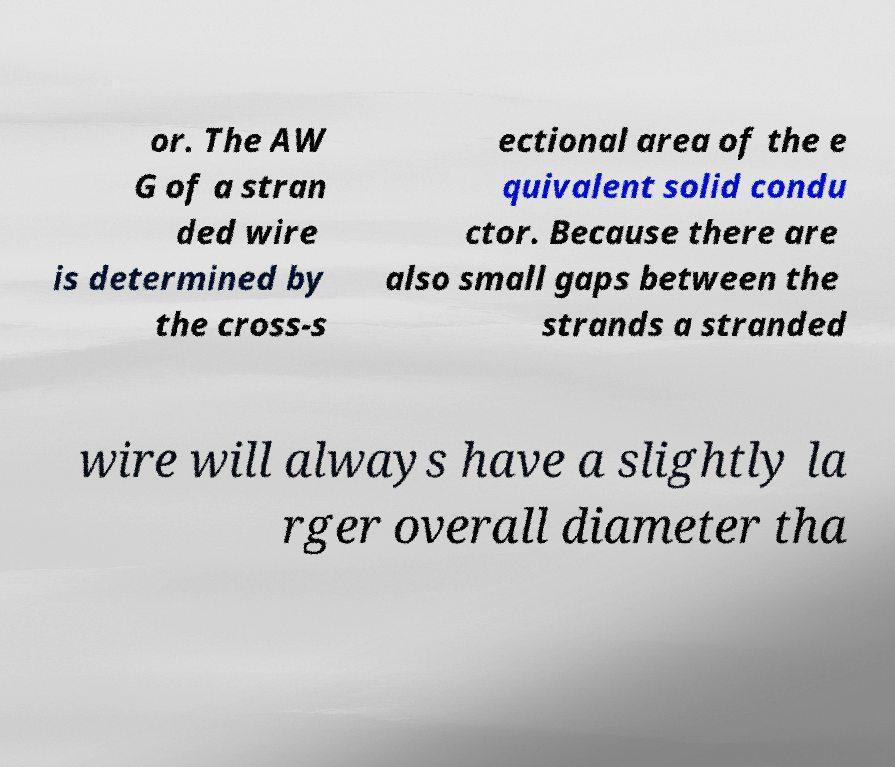Could you assist in decoding the text presented in this image and type it out clearly? or. The AW G of a stran ded wire is determined by the cross-s ectional area of the e quivalent solid condu ctor. Because there are also small gaps between the strands a stranded wire will always have a slightly la rger overall diameter tha 